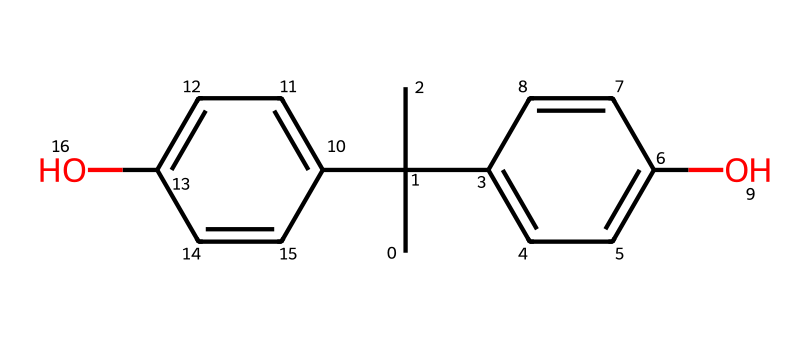What is the molecular formula of bisphenol A? First, by analyzing the SMILES representation, count the number of carbon (C), hydrogen (H), and oxygen (O) atoms. In this case, there are 15 carbon atoms, 16 hydrogen atoms, and 2 oxygen atoms. Therefore, the molecular formula is derived from this count.
Answer: C15H16O2 How many aromatic rings are present in bisphenol A? Examining the structure shows two distinct aromatic rings, as indicated by the alternating double bonds in the SMILES. Each benzene-like structure represents one aromatic ring. Therefore, there are a total of two rings.
Answer: 2 What type of functional groups are present in bisphenol A? The SMILES indicates the presence of hydroxyl groups (–OH), which are identified by the 'O' connected to hydrogen (H) in the structure. Therefore, the functional groups present are defined as hydroxyl groups.
Answer: hydroxyl groups Is bisphenol A symmetric or asymmetric? The structure reveals that bisphenol A has a symmetrical arrangement of the two aromatic rings around the central carbon backbone. As a result, this symmetry can easily be observed in the connectivity of the structure.
Answer: symmetric How does the presence of hydroxyl groups affect the solubility of bisphenol A? Hydroxyl groups increase the polarity of the molecule, allowing it to interact more favorably with water through hydrogen bonding. This interaction contributes to the solubility of bisphenol A in polar solvents.
Answer: increases solubility What is the significance of the biphenyl structure in bisphenol A? The biphenyl structure, which consists of two phenol (aromatic) groups linked by a carbon chain, contributes significantly to the chemical's stability and its applicability as a precursor in polymer production, particularly in plastics.
Answer: stability and polymer production 